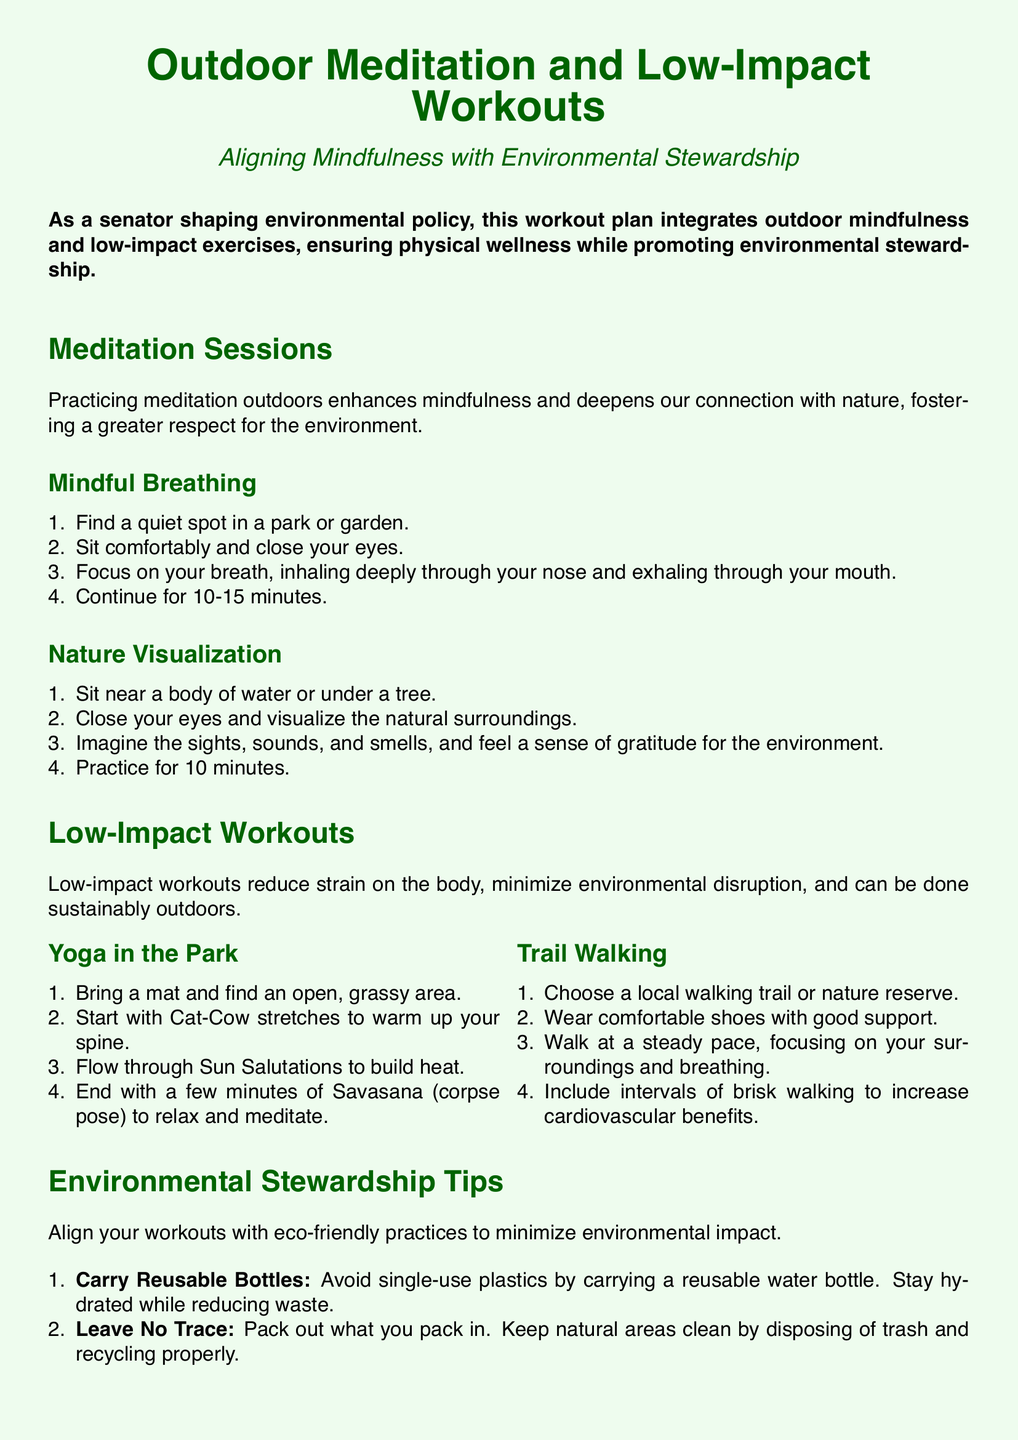What is the main focus of the workout plan? The main focus of the workout plan is to integrate outdoor mindfulness and low-impact exercises, ensuring physical wellness while promoting environmental stewardship.
Answer: Outdoor mindfulness and low-impact exercises How long should the Mindful Breathing session last? The Mindful Breathing session is recommended to last for 10-15 minutes.
Answer: 10-15 minutes What type of workout is suggested in a park? The document suggests practicing Yoga in the Park.
Answer: Yoga What is the first step in the Nature Visualization practice? The first step in the Nature Visualization practice is to sit near a body of water or under a tree.
Answer: Sit near a body of water or under a tree What environmentally friendly item should you carry during workouts? You should carry a reusable water bottle to avoid single-use plastics.
Answer: Reusable water bottle How can you support local parks according to the document? You can support local parks by participating in or donating to local park clean-up initiatives.
Answer: Participating in or donating to local park clean-up initiatives What is the purpose of Savasana in the Yoga workout? The purpose of Savasana is to relax and meditate after the workout.
Answer: To relax and meditate What should you do to minimize environmental impact during workouts? To minimize environmental impact, you should align your workouts with eco-friendly practices.
Answer: Align workouts with eco-friendly practices 